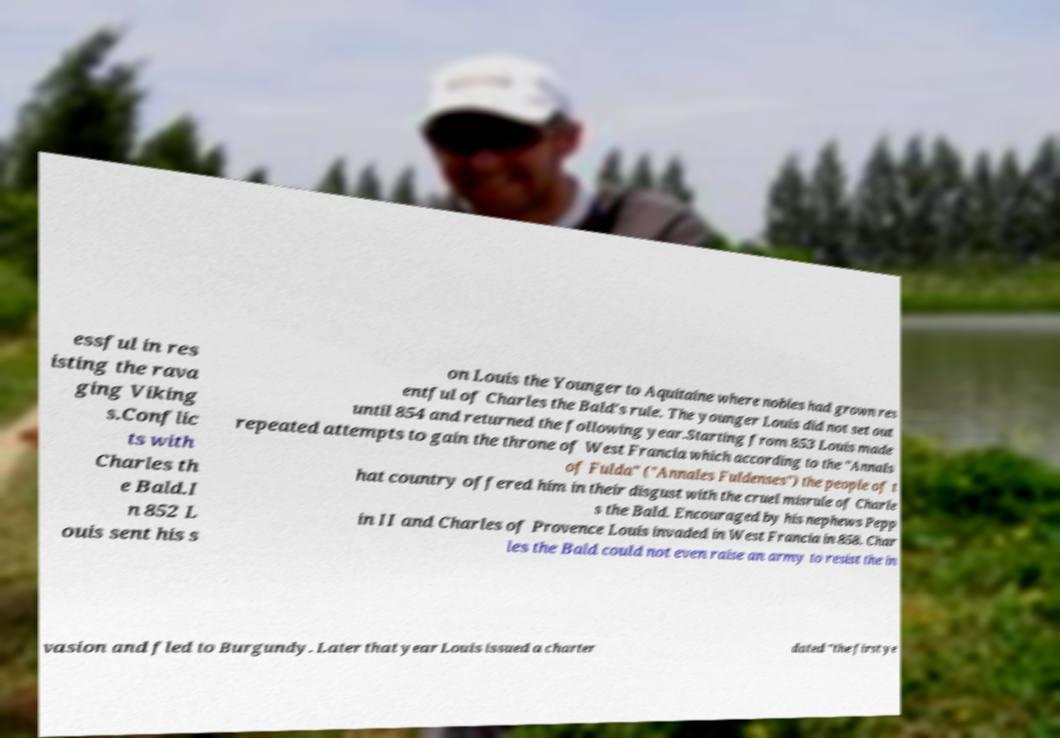Could you assist in decoding the text presented in this image and type it out clearly? essful in res isting the rava ging Viking s.Conflic ts with Charles th e Bald.I n 852 L ouis sent his s on Louis the Younger to Aquitaine where nobles had grown res entful of Charles the Bald's rule. The younger Louis did not set out until 854 and returned the following year.Starting from 853 Louis made repeated attempts to gain the throne of West Francia which according to the "Annals of Fulda" ("Annales Fuldenses") the people of t hat country offered him in their disgust with the cruel misrule of Charle s the Bald. Encouraged by his nephews Pepp in II and Charles of Provence Louis invaded in West Francia in 858. Char les the Bald could not even raise an army to resist the in vasion and fled to Burgundy. Later that year Louis issued a charter dated "the first ye 